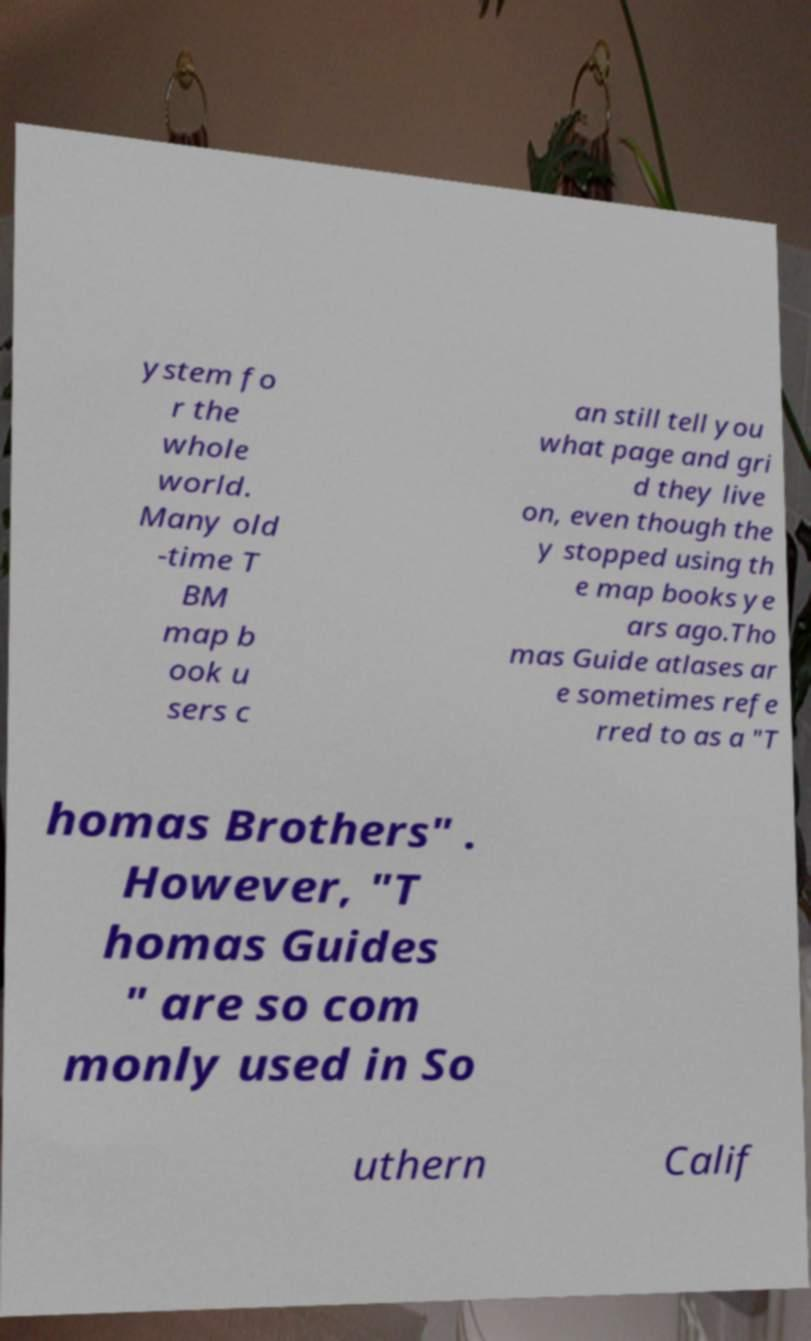Can you accurately transcribe the text from the provided image for me? ystem fo r the whole world. Many old -time T BM map b ook u sers c an still tell you what page and gri d they live on, even though the y stopped using th e map books ye ars ago.Tho mas Guide atlases ar e sometimes refe rred to as a "T homas Brothers" . However, "T homas Guides " are so com monly used in So uthern Calif 